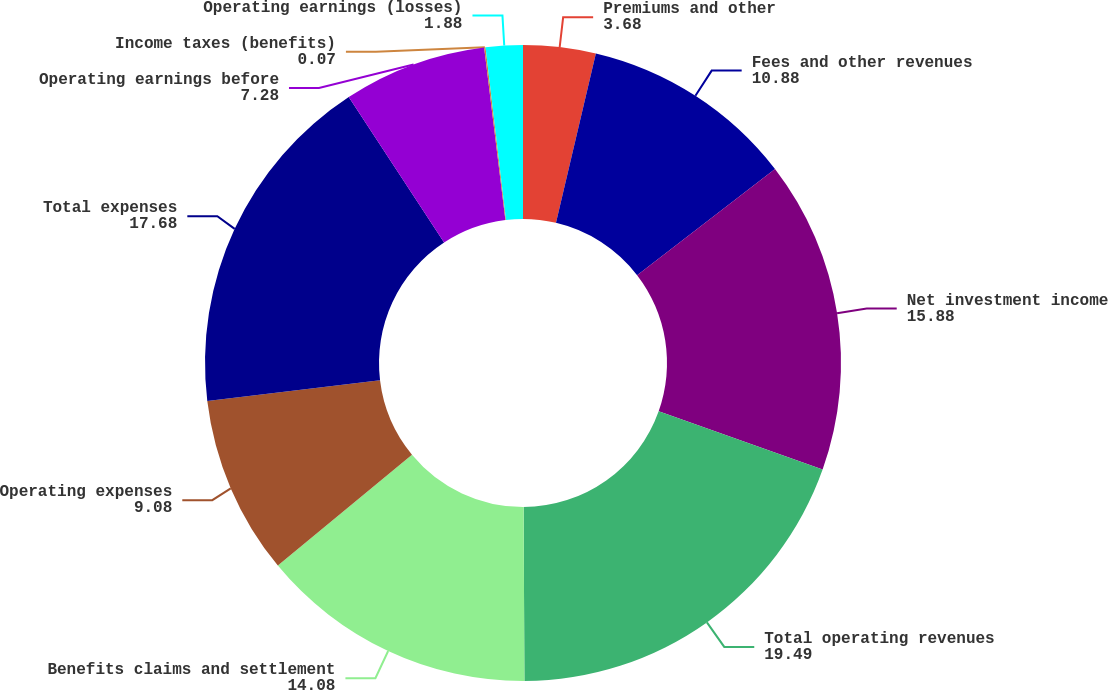<chart> <loc_0><loc_0><loc_500><loc_500><pie_chart><fcel>Premiums and other<fcel>Fees and other revenues<fcel>Net investment income<fcel>Total operating revenues<fcel>Benefits claims and settlement<fcel>Operating expenses<fcel>Total expenses<fcel>Operating earnings before<fcel>Income taxes (benefits)<fcel>Operating earnings (losses)<nl><fcel>3.68%<fcel>10.88%<fcel>15.88%<fcel>19.49%<fcel>14.08%<fcel>9.08%<fcel>17.68%<fcel>7.28%<fcel>0.07%<fcel>1.88%<nl></chart> 